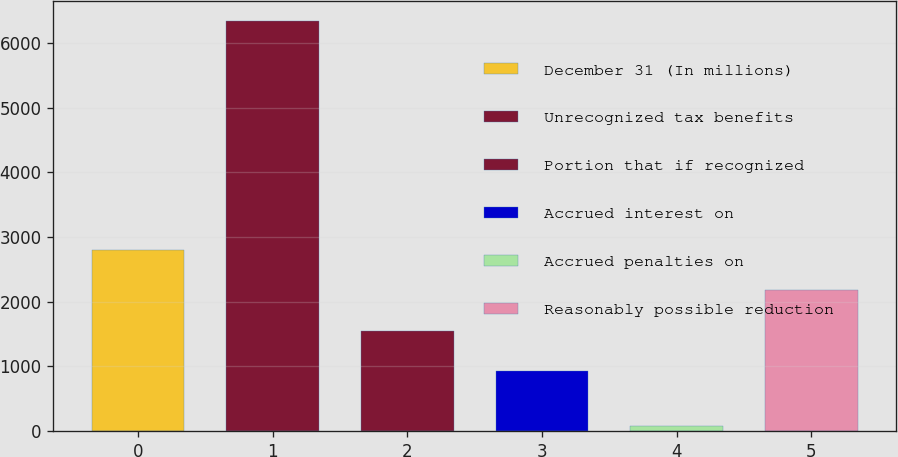Convert chart. <chart><loc_0><loc_0><loc_500><loc_500><bar_chart><fcel>December 31 (In millions)<fcel>Unrecognized tax benefits<fcel>Portion that if recognized<fcel>Accrued interest on<fcel>Accrued penalties on<fcel>Reasonably possible reduction<nl><fcel>2799.2<fcel>6331<fcel>1548.4<fcel>923<fcel>77<fcel>2173.8<nl></chart> 